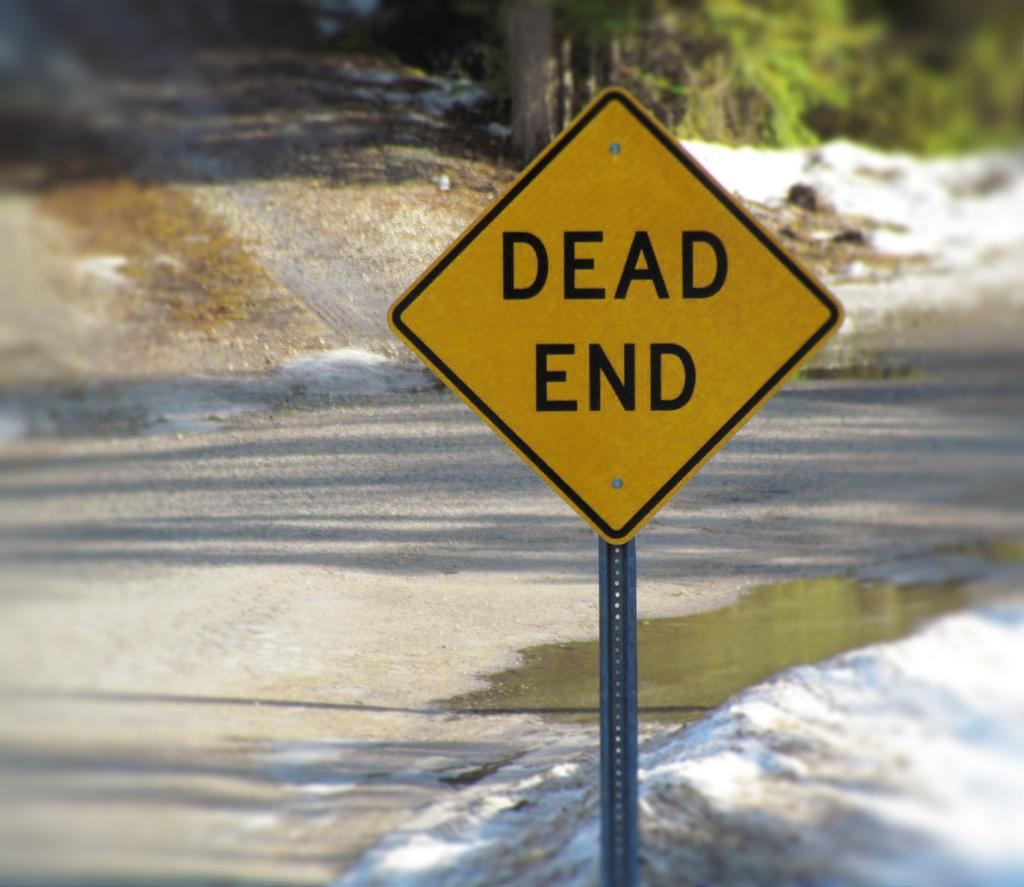<image>
Share a concise interpretation of the image provided. Yellow sign that says DEAD END on it. 